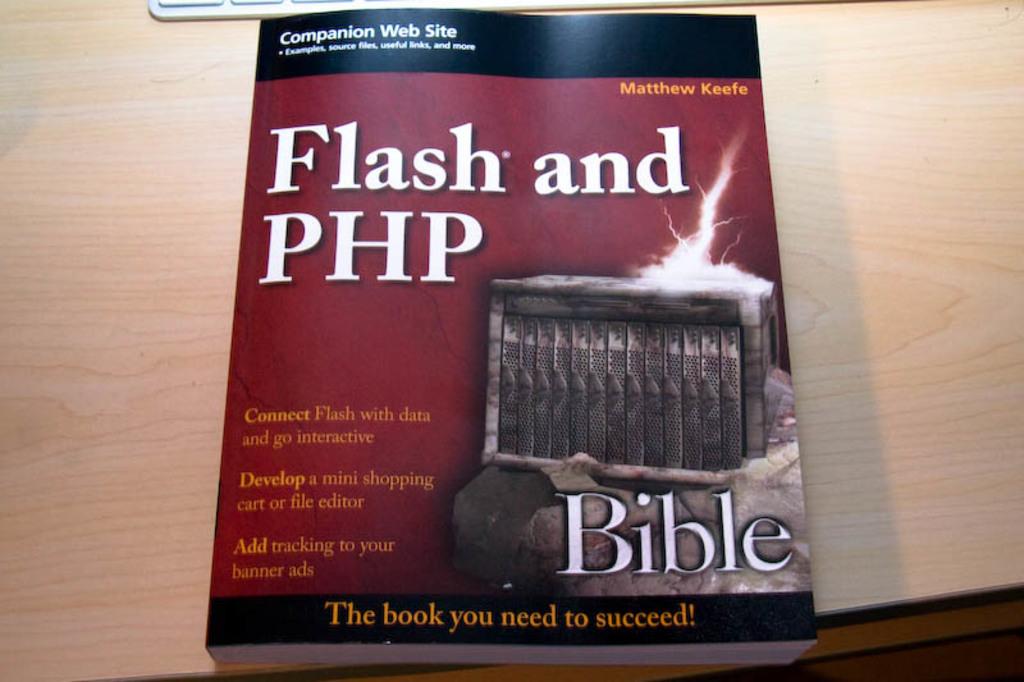Is this about the bible?
Your answer should be very brief. No. Why do you need this book?
Ensure brevity in your answer.  To succeed. 